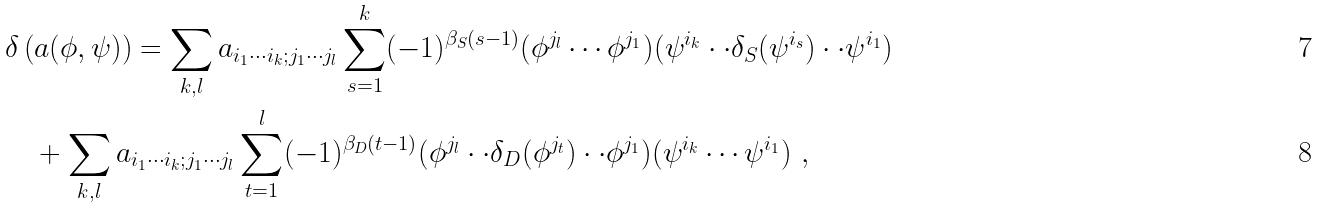<formula> <loc_0><loc_0><loc_500><loc_500>& \delta \left ( a ( \phi , \psi ) \right ) = \sum _ { k , l } a _ { i _ { 1 } \cdots i _ { k } ; j _ { 1 } \cdots j _ { l } } \sum _ { s = 1 } ^ { k } ( - 1 ) ^ { \beta _ { S } ( s - 1 ) } ( \phi ^ { j _ { l } } \cdots \phi ^ { j _ { 1 } } ) ( \psi ^ { i _ { k } } \cdot \cdot \delta _ { S } ( \psi ^ { i _ { s } } ) \cdot \cdot \psi ^ { i _ { 1 } } ) \\ & \quad + \sum _ { k , l } a _ { i _ { 1 } \cdots i _ { k } ; j _ { 1 } \cdots j _ { l } } \sum _ { t = 1 } ^ { l } ( - 1 ) ^ { \beta _ { D } ( t - 1 ) } ( \phi ^ { j _ { l } } \cdot \cdot \delta _ { D } ( \phi ^ { j _ { t } } ) \cdot \cdot \phi ^ { j _ { 1 } } ) ( \psi ^ { i _ { k } } \cdots \psi ^ { i _ { 1 } } ) \ ,</formula> 